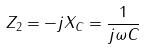Convert formula to latex. <formula><loc_0><loc_0><loc_500><loc_500>Z _ { 2 } = - j X _ { C } = \frac { 1 } { j \omega C }</formula> 